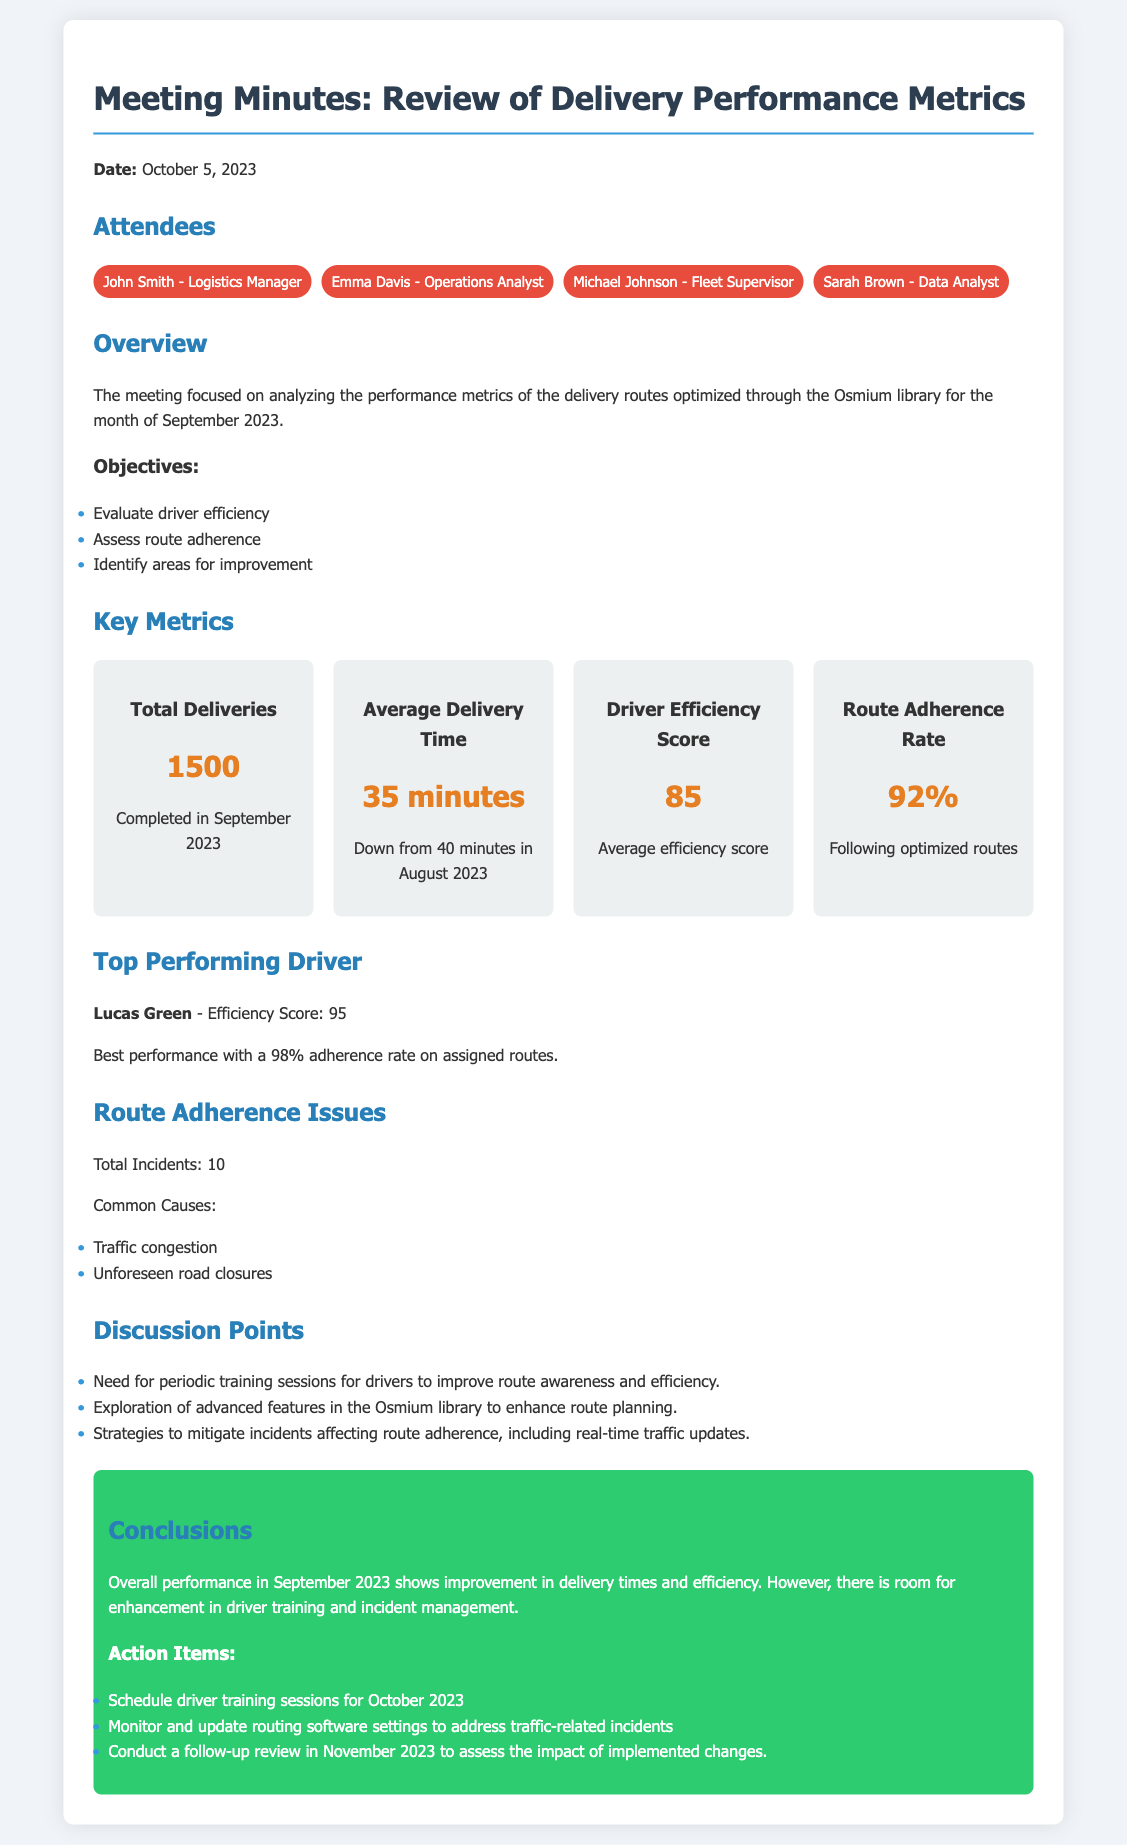What was the date of the meeting? The meeting was held on October 5, 2023.
Answer: October 5, 2023 How many total deliveries were completed in September 2023? The document states that 1500 deliveries were completed during that month.
Answer: 1500 What was the average delivery time recorded for September 2023? The average delivery time was mentioned as 35 minutes, which is an improvement from the previous month.
Answer: 35 minutes Who was the top-performing driver? The document identifies Lucas Green as the top-performing driver.
Answer: Lucas Green What was the Route Adherence Rate for September 2023? The document specifies that the Route Adherence Rate was 92%.
Answer: 92% How many incidents were reported that affected route adherence? The total number of incidents impacting route adherence is recorded as 10.
Answer: 10 What specific training need was discussed in the meeting? The attendees discussed the need for periodic training sessions for drivers.
Answer: Periodic training sessions What actions were recommended for October 2023? The action item includes scheduling driver training sessions for October 2023.
Answer: Schedule driver training sessions What was the efficiency score of the best performing driver? Lucas Green had an efficiency score of 95, as stated in the meeting minutes.
Answer: 95 